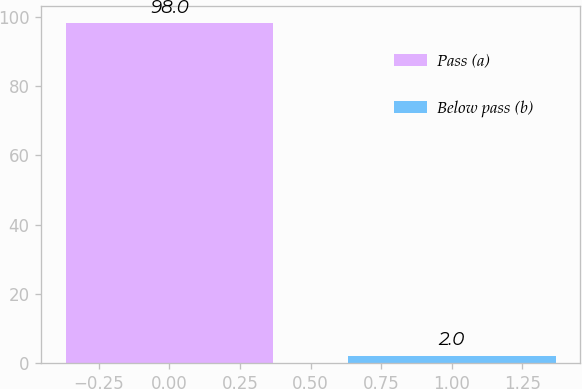<chart> <loc_0><loc_0><loc_500><loc_500><bar_chart><fcel>Pass (a)<fcel>Below pass (b)<nl><fcel>98<fcel>2<nl></chart> 